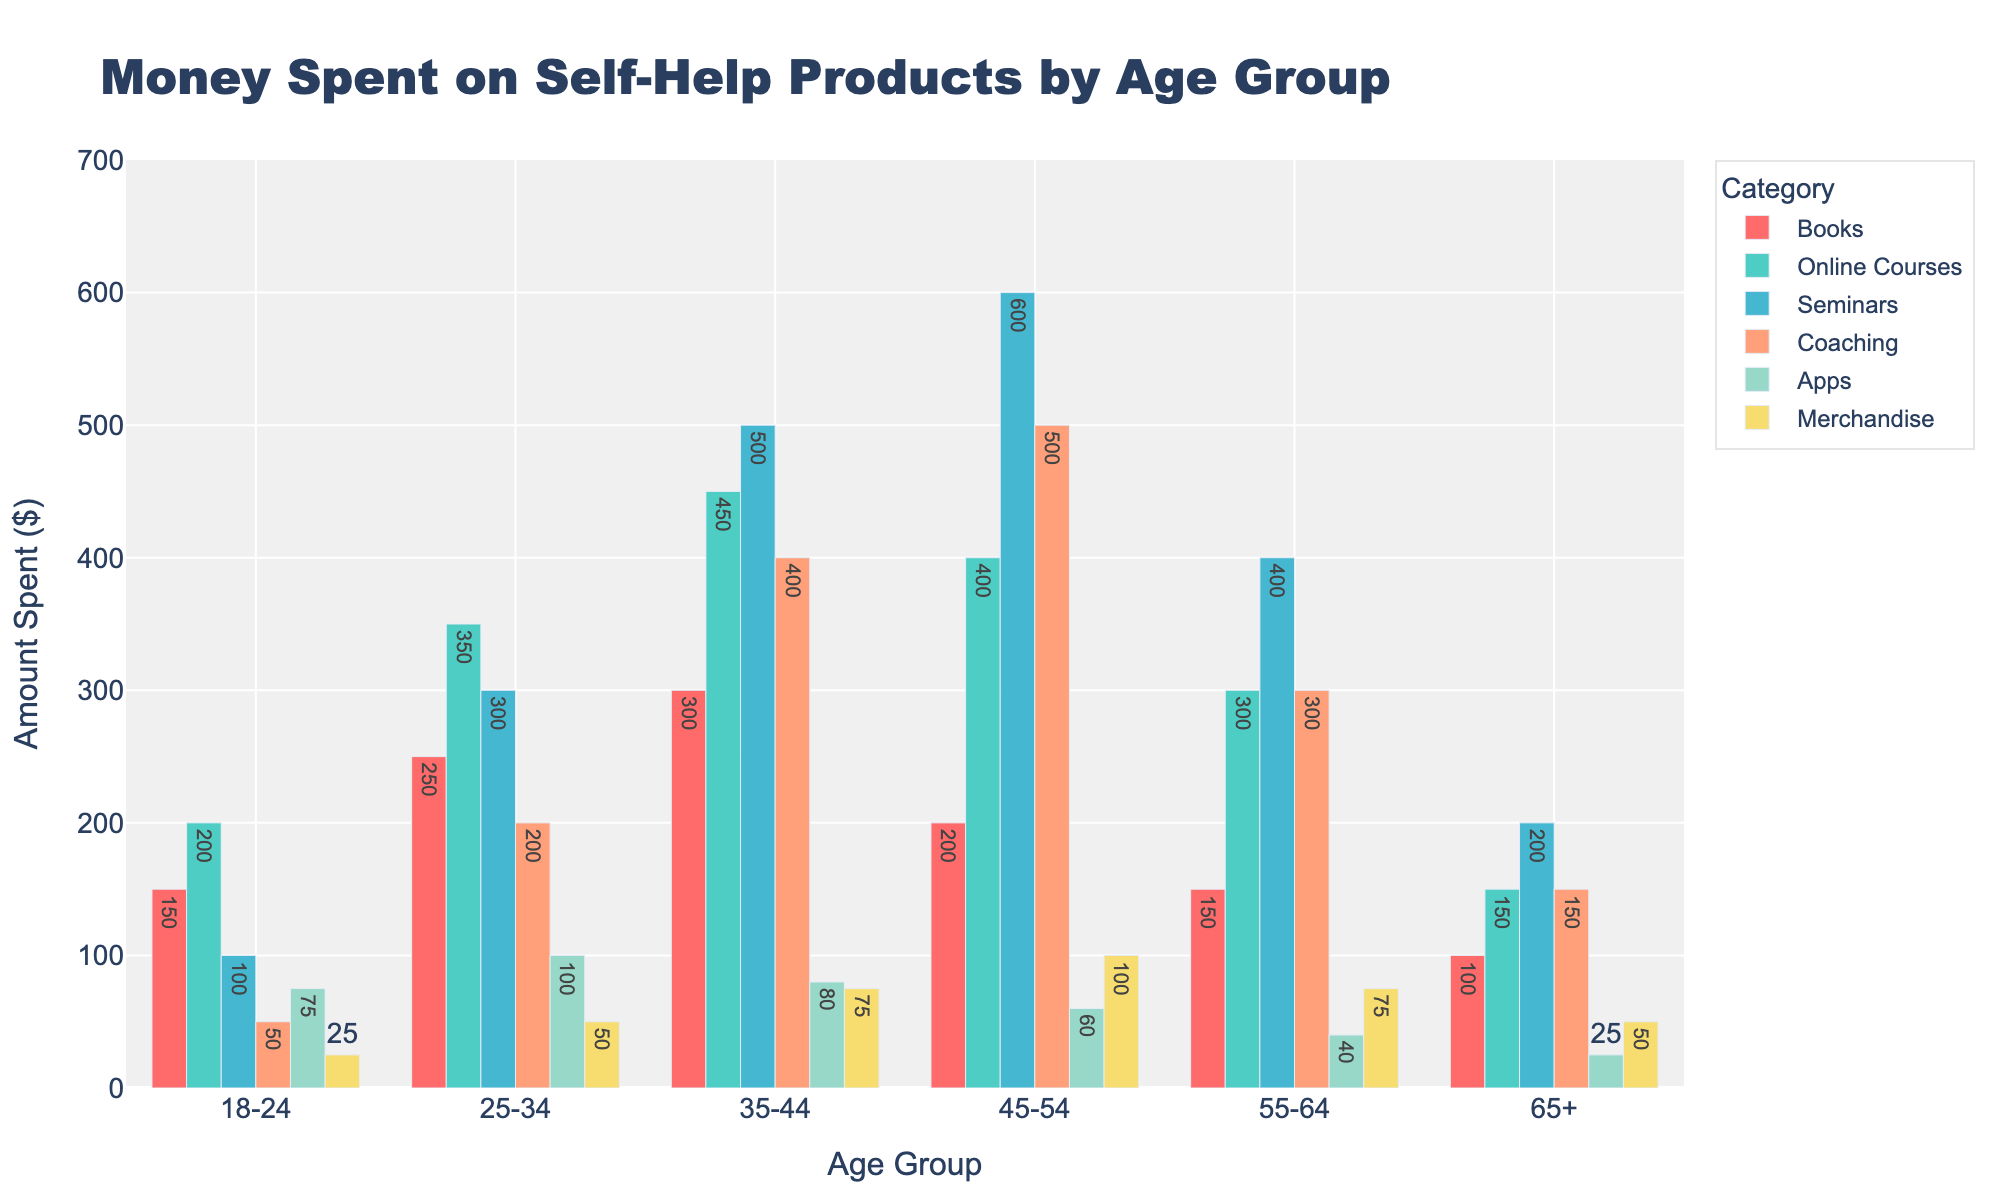What age group spends the most on seminars? The bar representing seminars for the age group 45-54 is the tallest, indicating it has the highest spending on seminars.
Answer: 45-54 Which category does the 35-44 age group spend the most on? In the 35-44 age group, the highest bar is for seminars, indicating the greatest spending in this category.
Answer: Seminars Which age group spends the least on apps? The age group 65+ has the smallest bar for apps, representing the least spending.
Answer: 65+ How much more do people aged 25-34 spend on online courses compared to people aged 18-24? The bar for online courses is 350 for ages 25-34 and 200 for ages 18-24. The difference is 350 - 200 = 150.
Answer: 150 Which age group has the lowest total spending on self-help products? By summing all the spending categories for each age group, the age group 65+ has the lowest total (100 + 150 + 200 + 150 + 25 + 50 = 675).
Answer: 65+ How does the spending on coaching for the 45-54 age group compare to that of the 55-64 age group? The bar for coaching is 500 for ages 45-54 and 300 for ages 55-64. Hence, the 45-54 age group spends more.
Answer: 45-54 spends more Which age group has a significantly lower spending on merchandise compared to others? The age group 18-24 has the shortest bar for merchandise, indicating significantly lower spending compared to other age groups.
Answer: 18-24 What's the difference in spending on books and seminars for the 35-44 age group? The 35-44 age group spends 300 on books and 500 on seminars. The difference is 500 - 300 = 200.
Answer: 200 Which age group spends the most on coaching? The tallest bar for coaching is found in the 45-54 age group, indicating the highest spending.
Answer: 45-54 How does the total spending of the 18-24 age group compare to the 55-64 age group? By summing all categories, 18-24: 150 + 200 + 100 + 50 + 75 + 25 = 600, and 55-64: 150 + 300 + 400 + 300 + 40 + 75 = 1265. The 55-64 age group spends more.
Answer: 55-64 spends more 